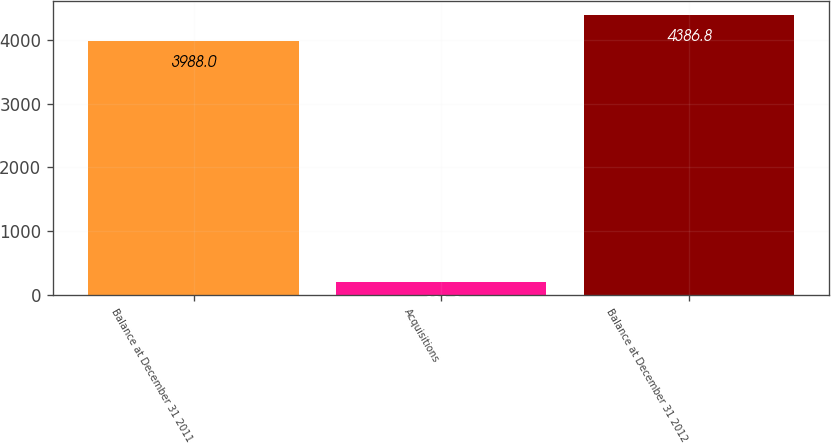Convert chart. <chart><loc_0><loc_0><loc_500><loc_500><bar_chart><fcel>Balance at December 31 2011<fcel>Acquisitions<fcel>Balance at December 31 2012<nl><fcel>3988<fcel>201<fcel>4386.8<nl></chart> 